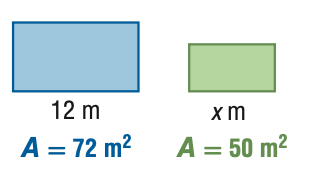Question: For the pair of similar figures, use the given areas to find x.
Choices:
A. 8.3
B. 10.0
C. 14.4
D. 17.3
Answer with the letter. Answer: B 